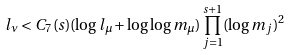Convert formula to latex. <formula><loc_0><loc_0><loc_500><loc_500>l _ { \nu } < C _ { 7 } ( s ) ( \log l _ { \mu } + \log \log m _ { \mu } ) \prod _ { j = 1 } ^ { s + 1 } ( \log m _ { j } ) ^ { 2 }</formula> 